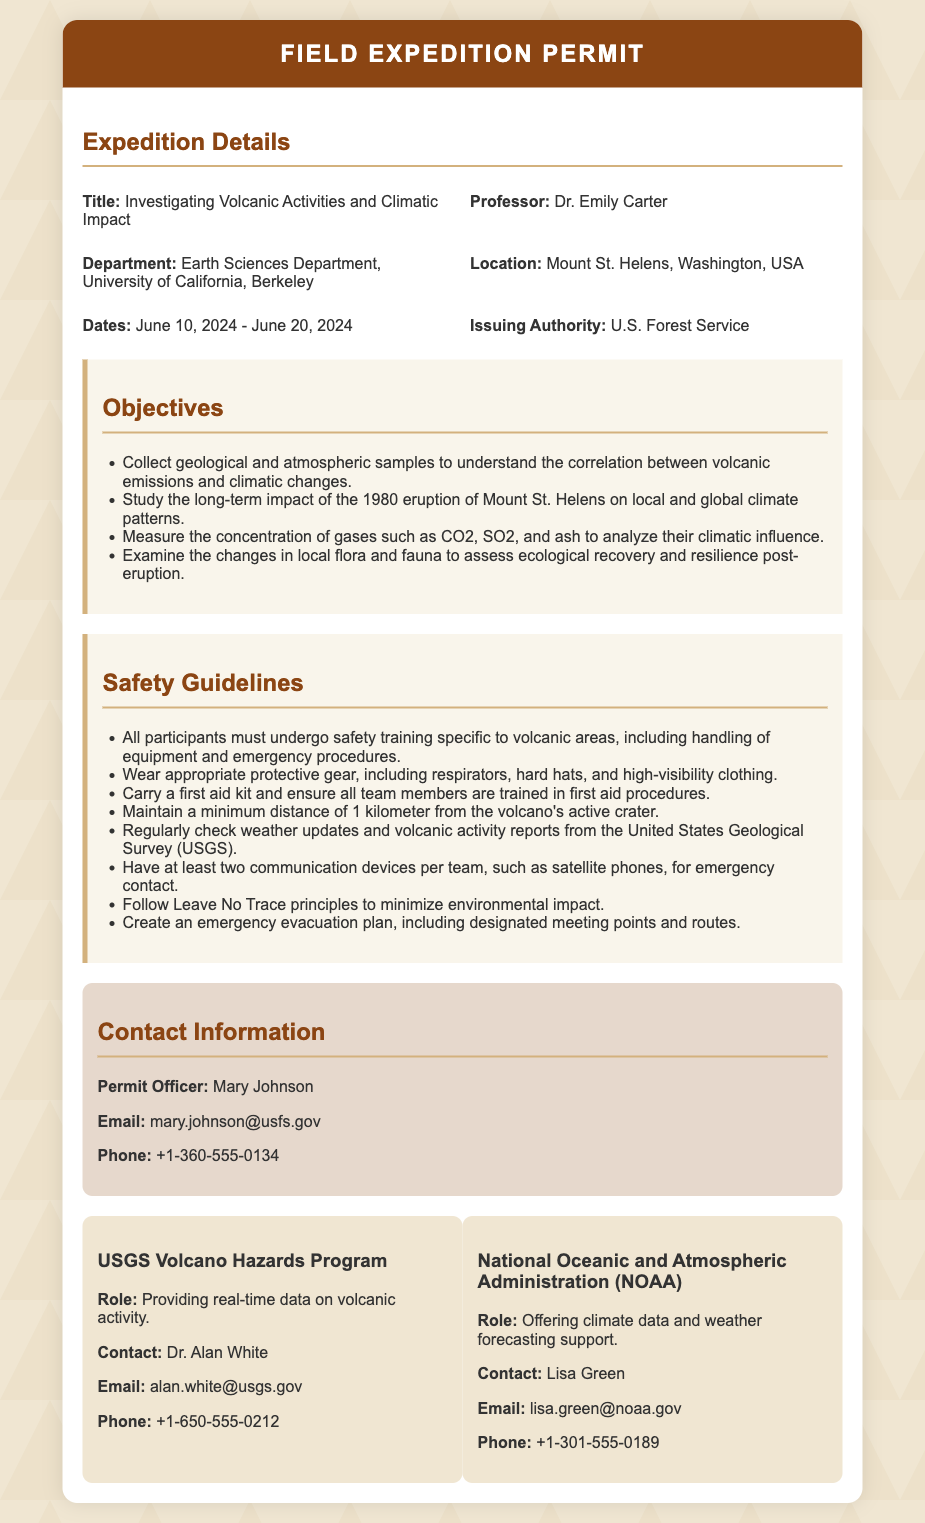What is the title of the expedition? The title is found at the beginning of the document under Expedition Details.
Answer: Investigating Volcanic Activities and Climatic Impact Who is the professor leading the expedition? The name of the professor can be found in the Expedition Details section.
Answer: Dr. Emily Carter What is the location of the expedition? The document specifies the location in the Expedition Details section.
Answer: Mount St. Helens, Washington, USA What are the expedition dates? The dates of the expedition are listed in the Expedition Details section.
Answer: June 10, 2024 - June 20, 2024 What is one objective of the expedition? Objectives are listed in the corresponding section, requiring identification of a specific item.
Answer: Collect geological and atmospheric samples How far must participants maintain distance from the volcano's active crater? This information is found within the Safety Guidelines section.
Answer: 1 kilometer What role does the USGS Volcano Hazards Program play? The role can be found in the support section of the document.
Answer: Providing real-time data on volcanic activity Who is the contact for the permit? This information is stated in the Contact Information section of the document.
Answer: Mary Johnson How many support teams are mentioned in the document? Count the support teams listed in the support section to answer.
Answer: Two 